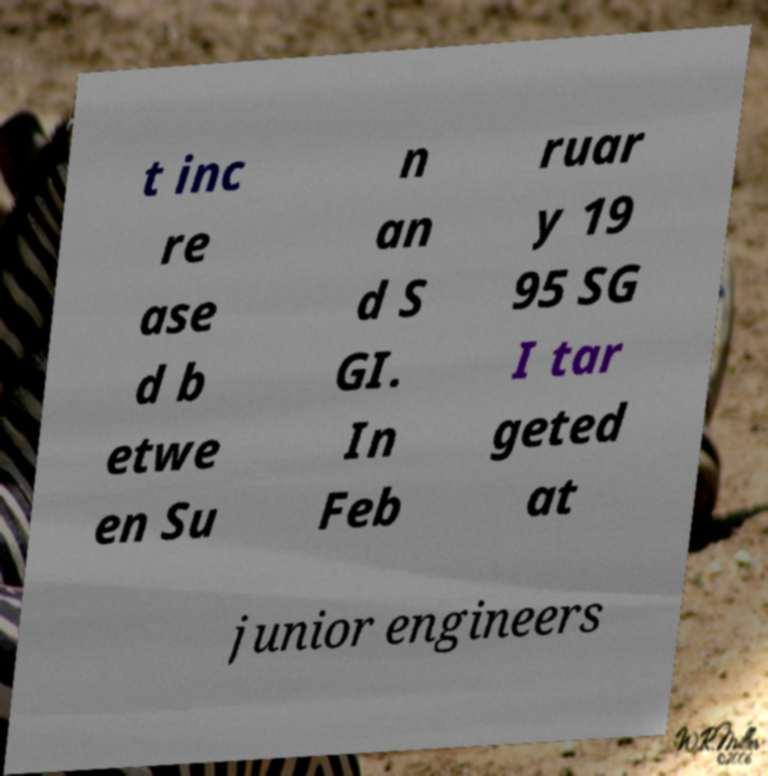Could you assist in decoding the text presented in this image and type it out clearly? t inc re ase d b etwe en Su n an d S GI. In Feb ruar y 19 95 SG I tar geted at junior engineers 